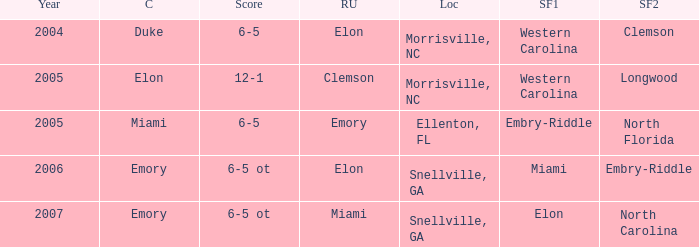When Embry-Riddle made it to the first semi finalist slot, list all the runners up. Emory. 